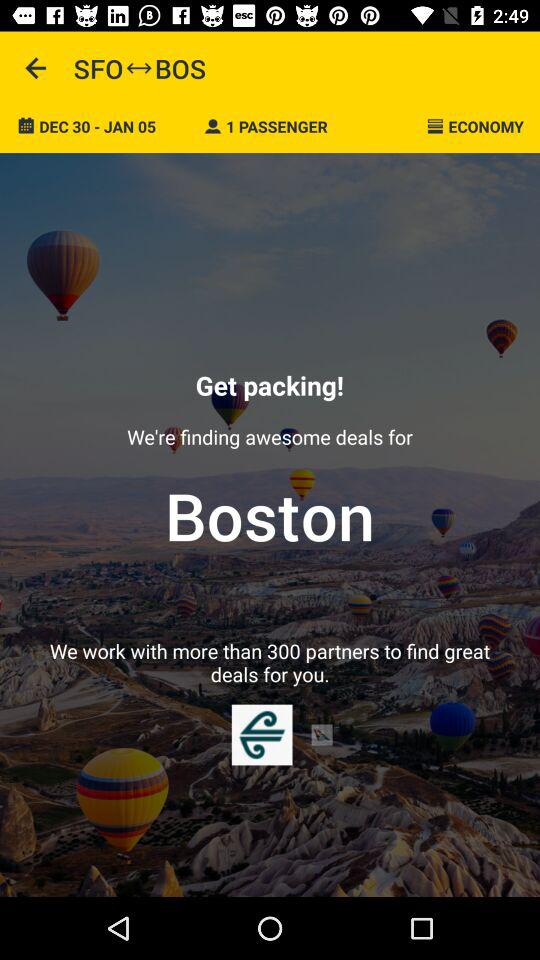How many passengers are there? There is 1 passenger. 